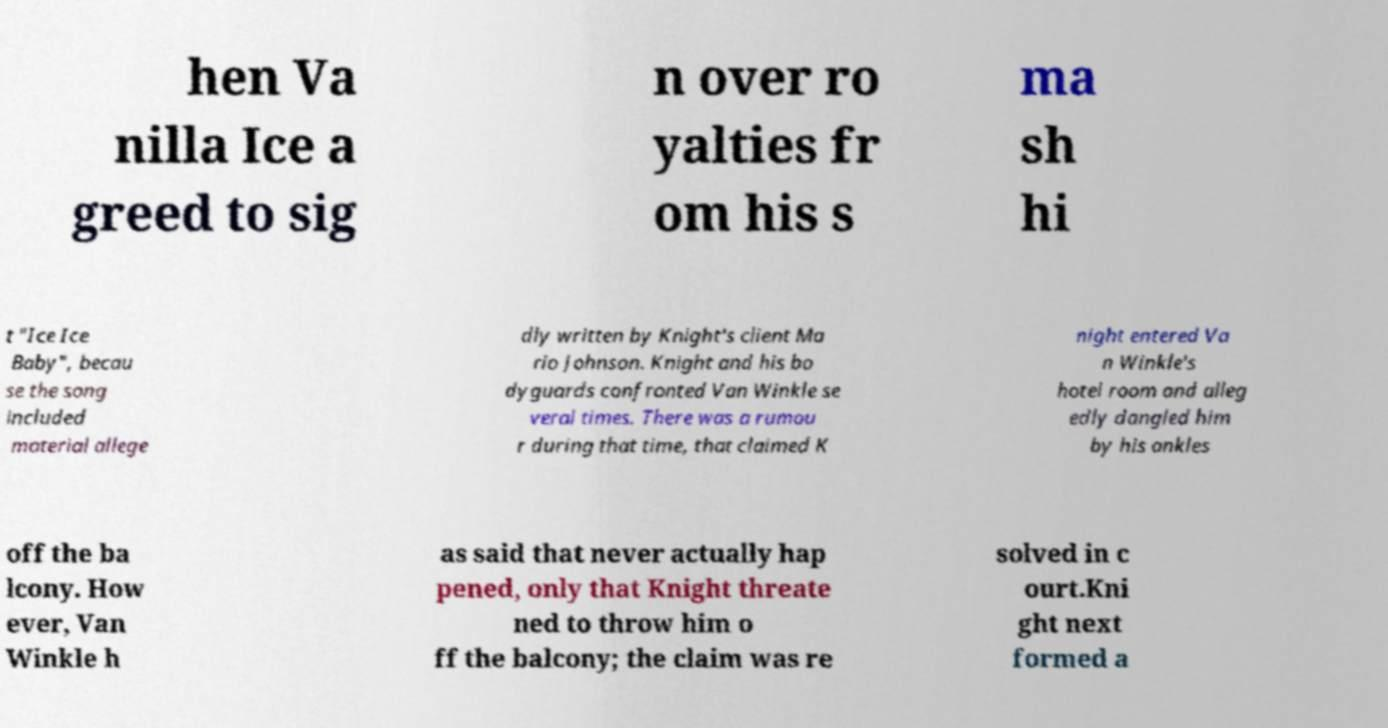Could you assist in decoding the text presented in this image and type it out clearly? hen Va nilla Ice a greed to sig n over ro yalties fr om his s ma sh hi t "Ice Ice Baby", becau se the song included material allege dly written by Knight's client Ma rio Johnson. Knight and his bo dyguards confronted Van Winkle se veral times. There was a rumou r during that time, that claimed K night entered Va n Winkle's hotel room and alleg edly dangled him by his ankles off the ba lcony. How ever, Van Winkle h as said that never actually hap pened, only that Knight threate ned to throw him o ff the balcony; the claim was re solved in c ourt.Kni ght next formed a 